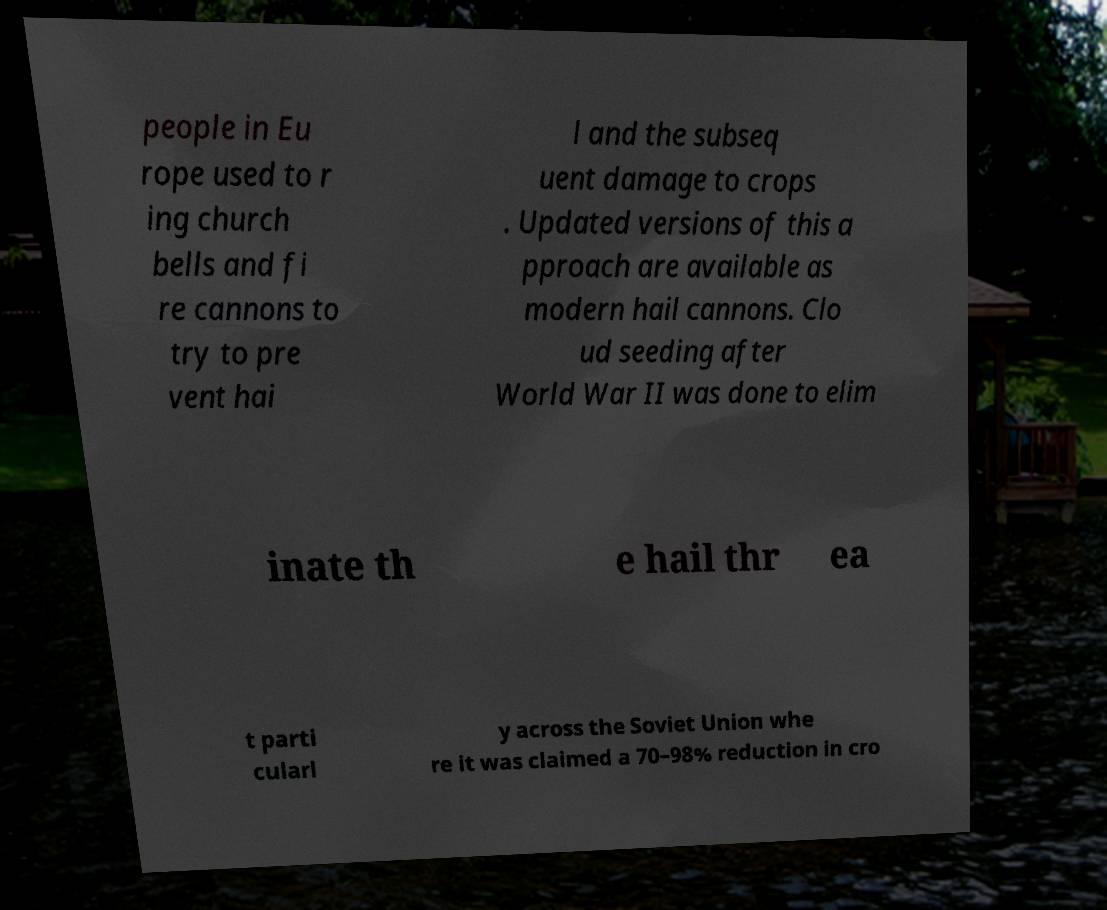Could you extract and type out the text from this image? people in Eu rope used to r ing church bells and fi re cannons to try to pre vent hai l and the subseq uent damage to crops . Updated versions of this a pproach are available as modern hail cannons. Clo ud seeding after World War II was done to elim inate th e hail thr ea t parti cularl y across the Soviet Union whe re it was claimed a 70–98% reduction in cro 